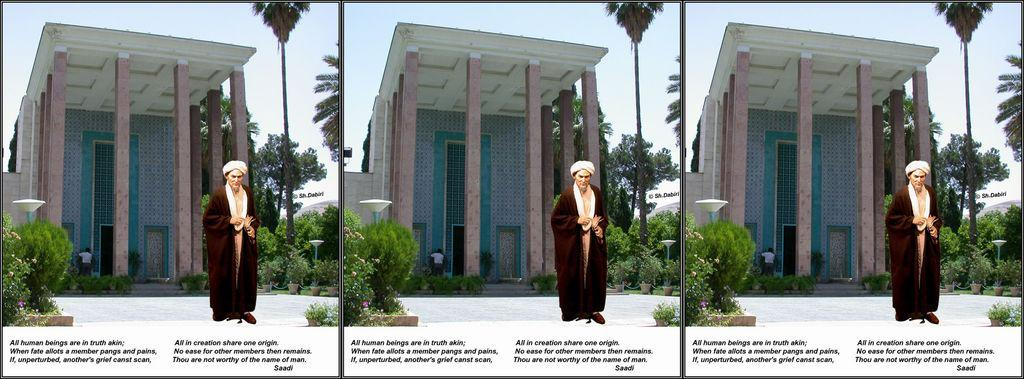What is the composition of the collage in the image? The collage consists of three same images. What is present in each of the images? There is a person, a building, trees, garden plants, objects at the top of poles, and the sky in each image. Can you describe the objects at the top of the poles in each image? Unfortunately, the details of the objects at the top of the poles cannot be discerned from the image. How many stems can be seen growing from the trees in the image? There are no stems growing from the trees in the image; the trees are not depicted in a way that allows us to see individual stems. 